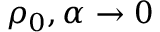Convert formula to latex. <formula><loc_0><loc_0><loc_500><loc_500>\rho _ { 0 } , \alpha \rightarrow 0</formula> 